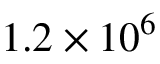Convert formula to latex. <formula><loc_0><loc_0><loc_500><loc_500>1 . 2 \times 1 0 ^ { 6 }</formula> 